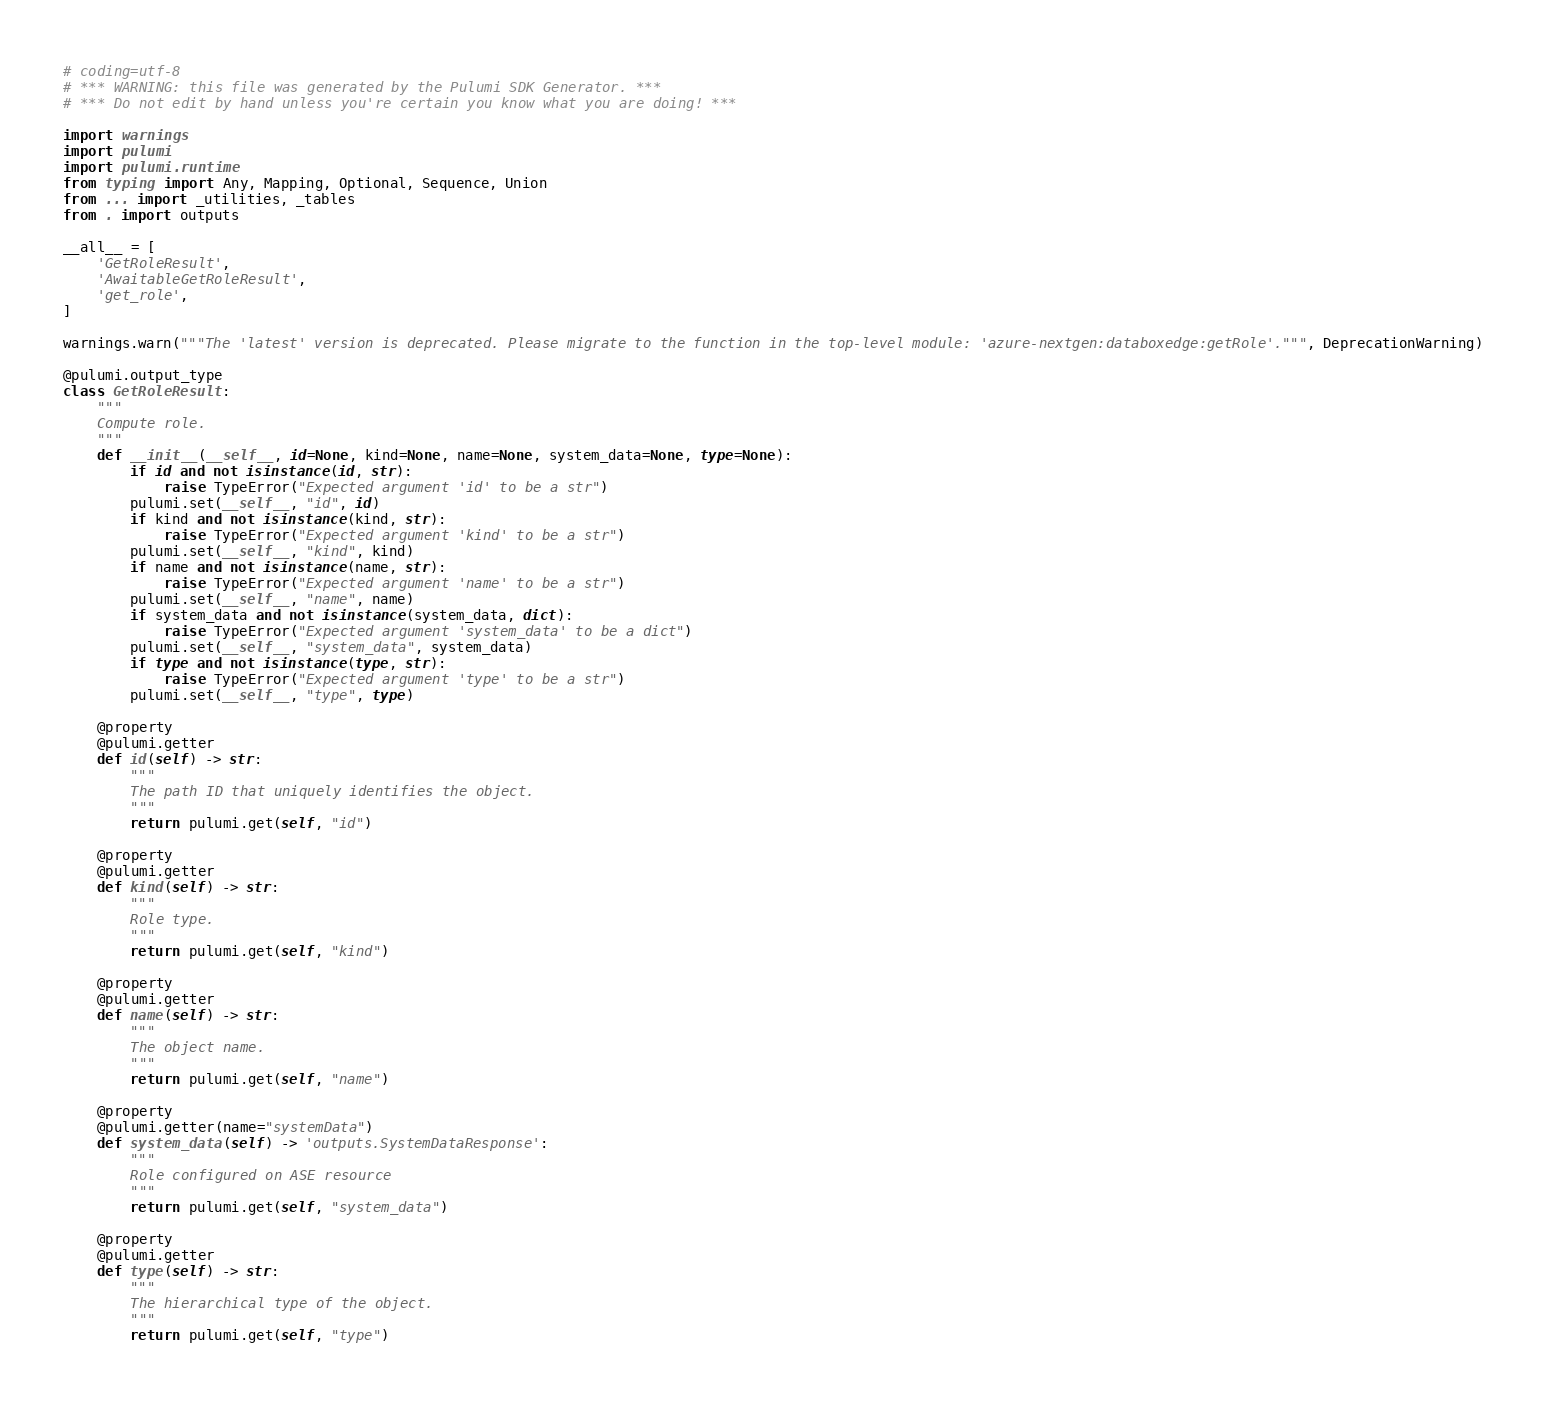Convert code to text. <code><loc_0><loc_0><loc_500><loc_500><_Python_># coding=utf-8
# *** WARNING: this file was generated by the Pulumi SDK Generator. ***
# *** Do not edit by hand unless you're certain you know what you are doing! ***

import warnings
import pulumi
import pulumi.runtime
from typing import Any, Mapping, Optional, Sequence, Union
from ... import _utilities, _tables
from . import outputs

__all__ = [
    'GetRoleResult',
    'AwaitableGetRoleResult',
    'get_role',
]

warnings.warn("""The 'latest' version is deprecated. Please migrate to the function in the top-level module: 'azure-nextgen:databoxedge:getRole'.""", DeprecationWarning)

@pulumi.output_type
class GetRoleResult:
    """
    Compute role.
    """
    def __init__(__self__, id=None, kind=None, name=None, system_data=None, type=None):
        if id and not isinstance(id, str):
            raise TypeError("Expected argument 'id' to be a str")
        pulumi.set(__self__, "id", id)
        if kind and not isinstance(kind, str):
            raise TypeError("Expected argument 'kind' to be a str")
        pulumi.set(__self__, "kind", kind)
        if name and not isinstance(name, str):
            raise TypeError("Expected argument 'name' to be a str")
        pulumi.set(__self__, "name", name)
        if system_data and not isinstance(system_data, dict):
            raise TypeError("Expected argument 'system_data' to be a dict")
        pulumi.set(__self__, "system_data", system_data)
        if type and not isinstance(type, str):
            raise TypeError("Expected argument 'type' to be a str")
        pulumi.set(__self__, "type", type)

    @property
    @pulumi.getter
    def id(self) -> str:
        """
        The path ID that uniquely identifies the object.
        """
        return pulumi.get(self, "id")

    @property
    @pulumi.getter
    def kind(self) -> str:
        """
        Role type.
        """
        return pulumi.get(self, "kind")

    @property
    @pulumi.getter
    def name(self) -> str:
        """
        The object name.
        """
        return pulumi.get(self, "name")

    @property
    @pulumi.getter(name="systemData")
    def system_data(self) -> 'outputs.SystemDataResponse':
        """
        Role configured on ASE resource
        """
        return pulumi.get(self, "system_data")

    @property
    @pulumi.getter
    def type(self) -> str:
        """
        The hierarchical type of the object.
        """
        return pulumi.get(self, "type")

</code> 